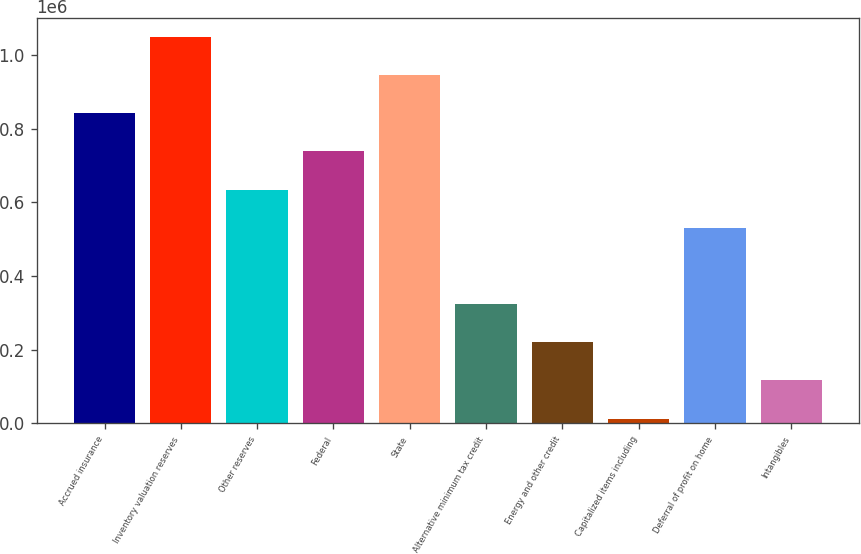Convert chart. <chart><loc_0><loc_0><loc_500><loc_500><bar_chart><fcel>Accrued insurance<fcel>Inventory valuation reserves<fcel>Other reserves<fcel>Federal<fcel>State<fcel>Alternative minimum tax credit<fcel>Energy and other credit<fcel>Capitalized items including<fcel>Deferral of profit on home<fcel>Intangibles<nl><fcel>842137<fcel>1.04941e+06<fcel>634866<fcel>738502<fcel>945773<fcel>323960<fcel>220325<fcel>13054<fcel>531231<fcel>116689<nl></chart> 